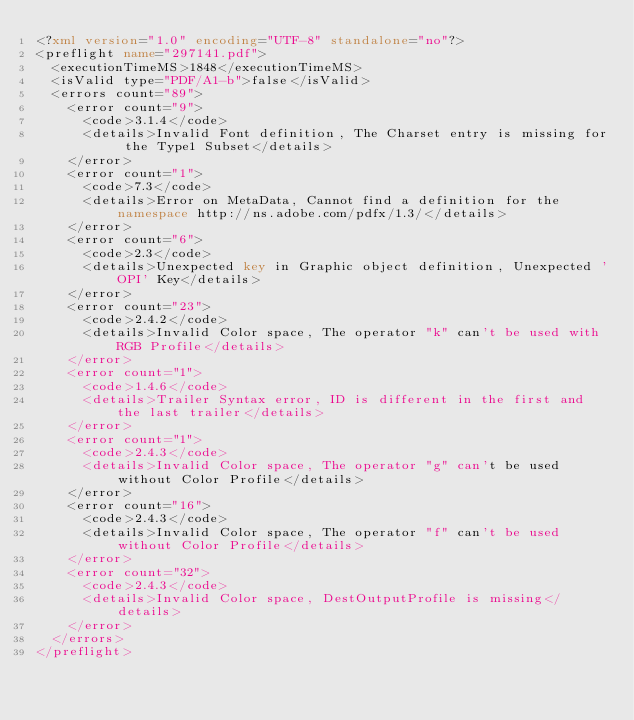Convert code to text. <code><loc_0><loc_0><loc_500><loc_500><_XML_><?xml version="1.0" encoding="UTF-8" standalone="no"?>
<preflight name="297141.pdf">
  <executionTimeMS>1848</executionTimeMS>
  <isValid type="PDF/A1-b">false</isValid>
  <errors count="89">
    <error count="9">
      <code>3.1.4</code>
      <details>Invalid Font definition, The Charset entry is missing for the Type1 Subset</details>
    </error>
    <error count="1">
      <code>7.3</code>
      <details>Error on MetaData, Cannot find a definition for the namespace http://ns.adobe.com/pdfx/1.3/</details>
    </error>
    <error count="6">
      <code>2.3</code>
      <details>Unexpected key in Graphic object definition, Unexpected 'OPI' Key</details>
    </error>
    <error count="23">
      <code>2.4.2</code>
      <details>Invalid Color space, The operator "k" can't be used with RGB Profile</details>
    </error>
    <error count="1">
      <code>1.4.6</code>
      <details>Trailer Syntax error, ID is different in the first and the last trailer</details>
    </error>
    <error count="1">
      <code>2.4.3</code>
      <details>Invalid Color space, The operator "g" can't be used without Color Profile</details>
    </error>
    <error count="16">
      <code>2.4.3</code>
      <details>Invalid Color space, The operator "f" can't be used without Color Profile</details>
    </error>
    <error count="32">
      <code>2.4.3</code>
      <details>Invalid Color space, DestOutputProfile is missing</details>
    </error>
  </errors>
</preflight>
</code> 